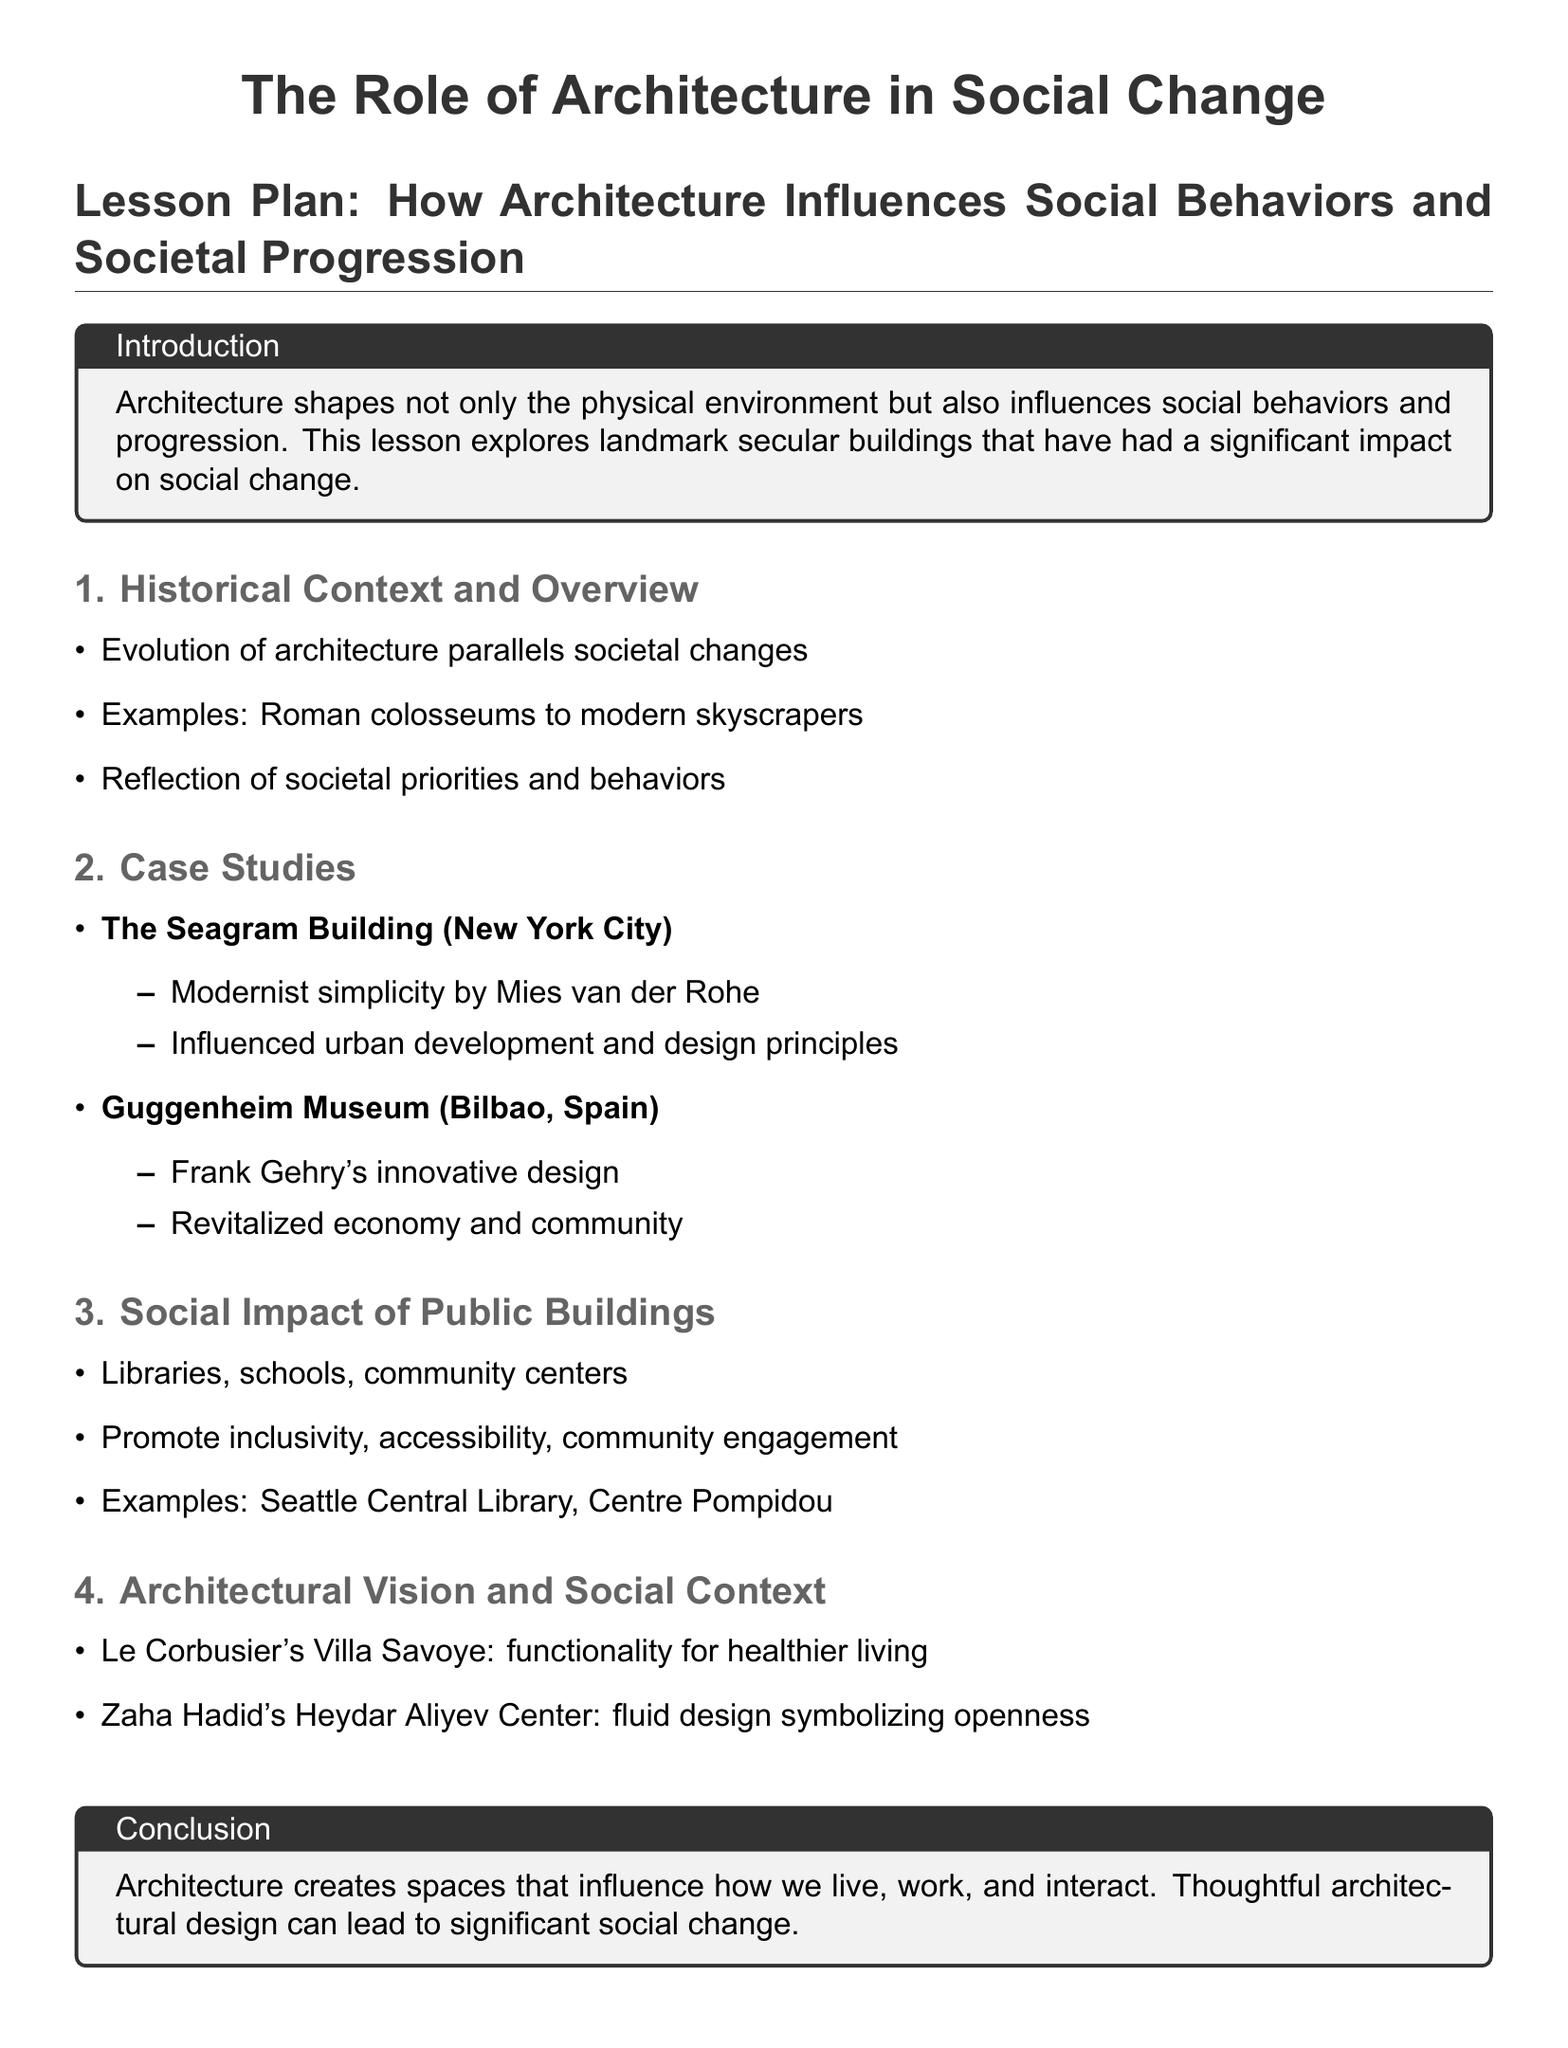What is the title of the lesson plan? The title is stated at the beginning of the document, which is "The Role of Architecture in Social Change."
Answer: The Role of Architecture in Social Change Who wrote the Seagram Building? The document specifies that the Seagram Building was designed by Mies van der Rohe.
Answer: Mies van der Rohe What building is associated with Frank Gehry? The document mentions the Guggenheim Museum located in Bilbao, Spain, as a work by Frank Gehry.
Answer: Guggenheim Museum What is one example of a public building discussed? The document lists examples such as the Seattle Central Library and the Centre Pompidou under public buildings.
Answer: Seattle Central Library What architectural vision is associated with Le Corbusier? The document references Le Corbusier's Villa Savoye and its focus on functionality for healthier living.
Answer: Villa Savoye How does architecture influence society according to the document? The introduction describes architecture as shaping the physical environment and influencing social behaviors and progression.
Answer: Influences social behaviors and progression What does Zaha Hadid’s Heydar Aliyev Center symbolize? The document describes the Heydar Aliyev Center's design as symbolizing openness.
Answer: Openness How many case studies are mentioned in the document? The document lists two case studies: the Seagram Building and the Guggenheim Museum.
Answer: Two What role do public buildings play according to the lesson plan? The document states that public buildings promote inclusivity, accessibility, and community engagement.
Answer: Promote inclusivity, accessibility, community engagement 